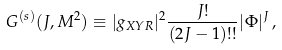<formula> <loc_0><loc_0><loc_500><loc_500>G ^ { ( s ) } ( J , M ^ { 2 } ) \equiv | g _ { X Y R } | ^ { 2 } \frac { J ! } { ( 2 J - 1 ) ! ! } | \Phi | ^ { J } \, ,</formula> 